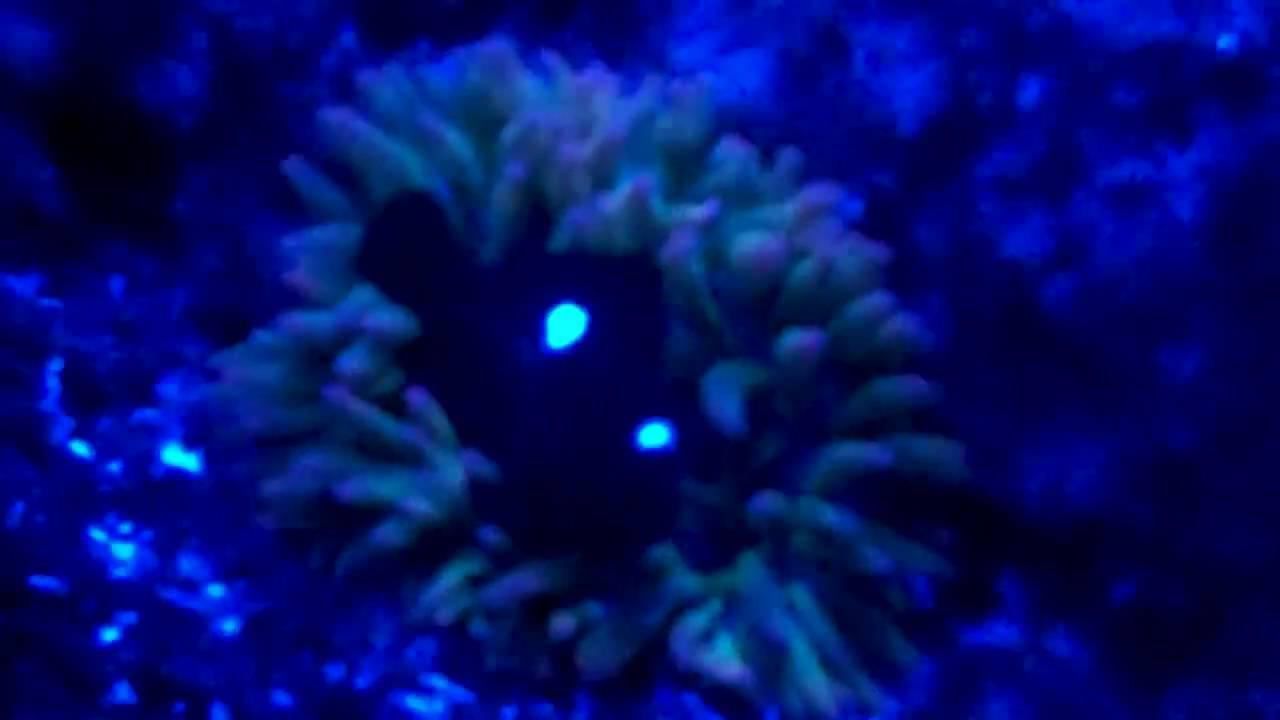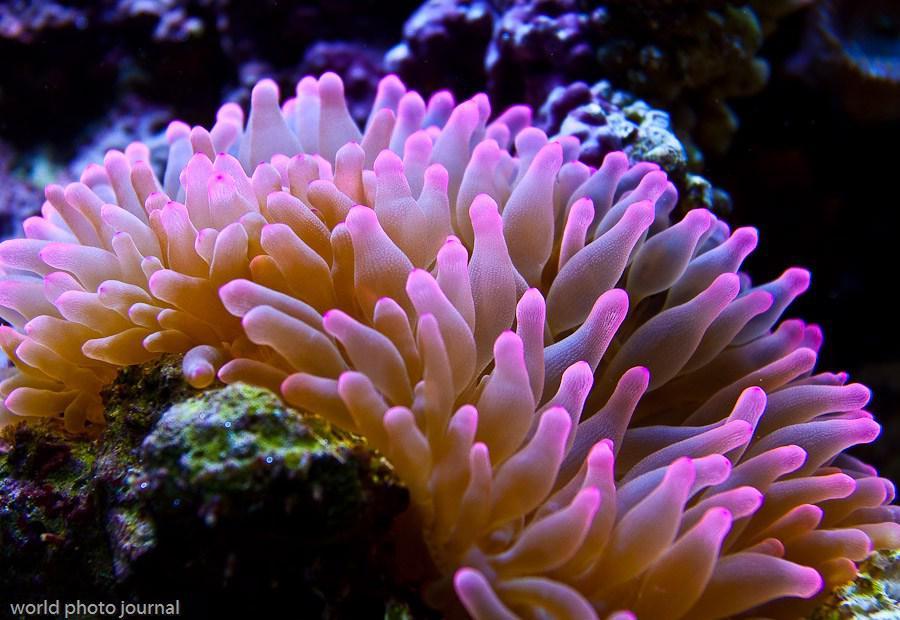The first image is the image on the left, the second image is the image on the right. Evaluate the accuracy of this statement regarding the images: "At least one fish is orange.". Is it true? Answer yes or no. No. 